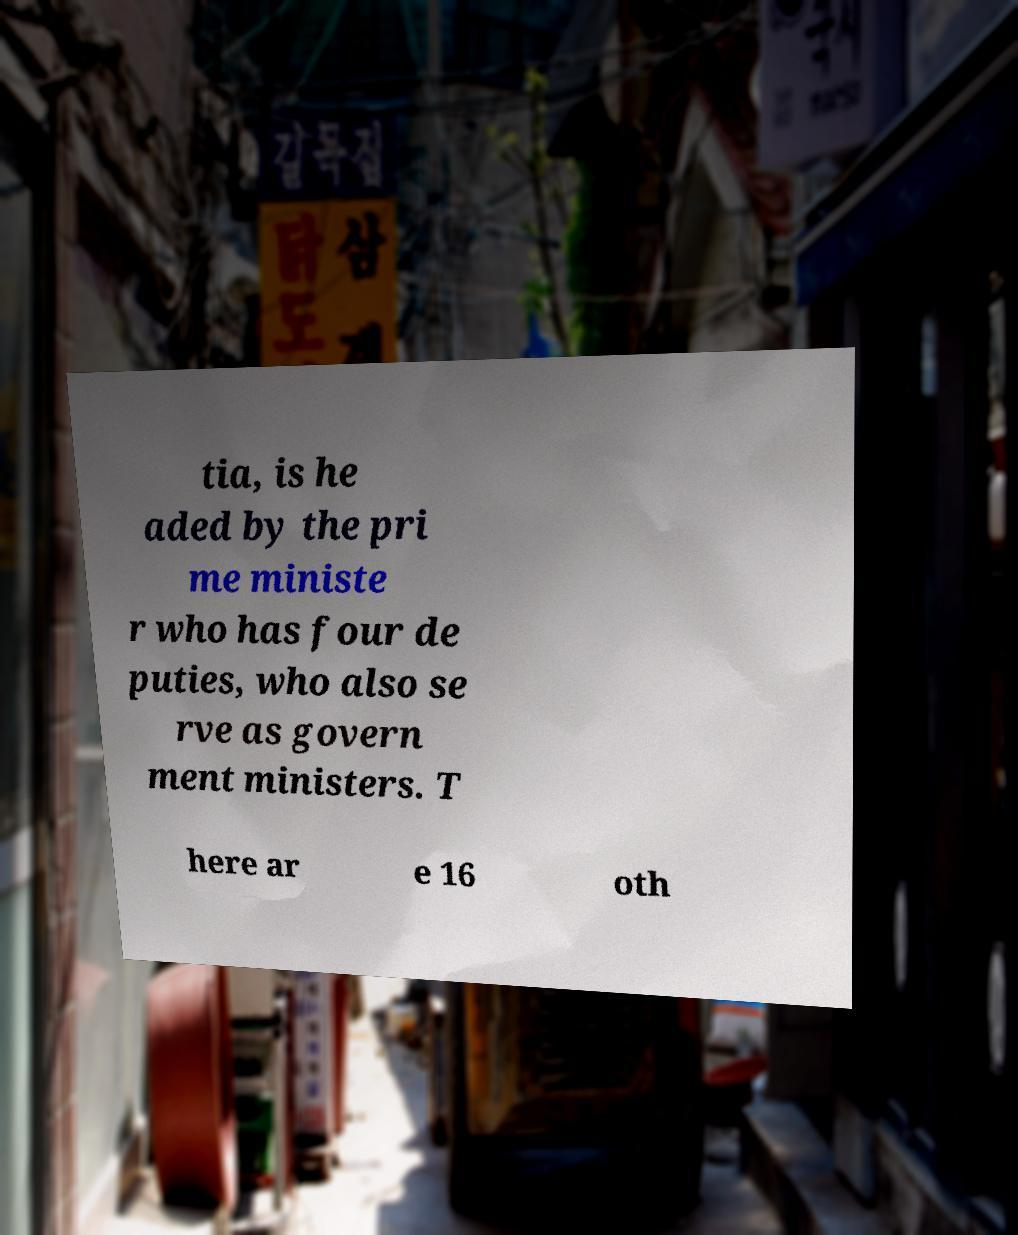Please read and relay the text visible in this image. What does it say? tia, is he aded by the pri me ministe r who has four de puties, who also se rve as govern ment ministers. T here ar e 16 oth 